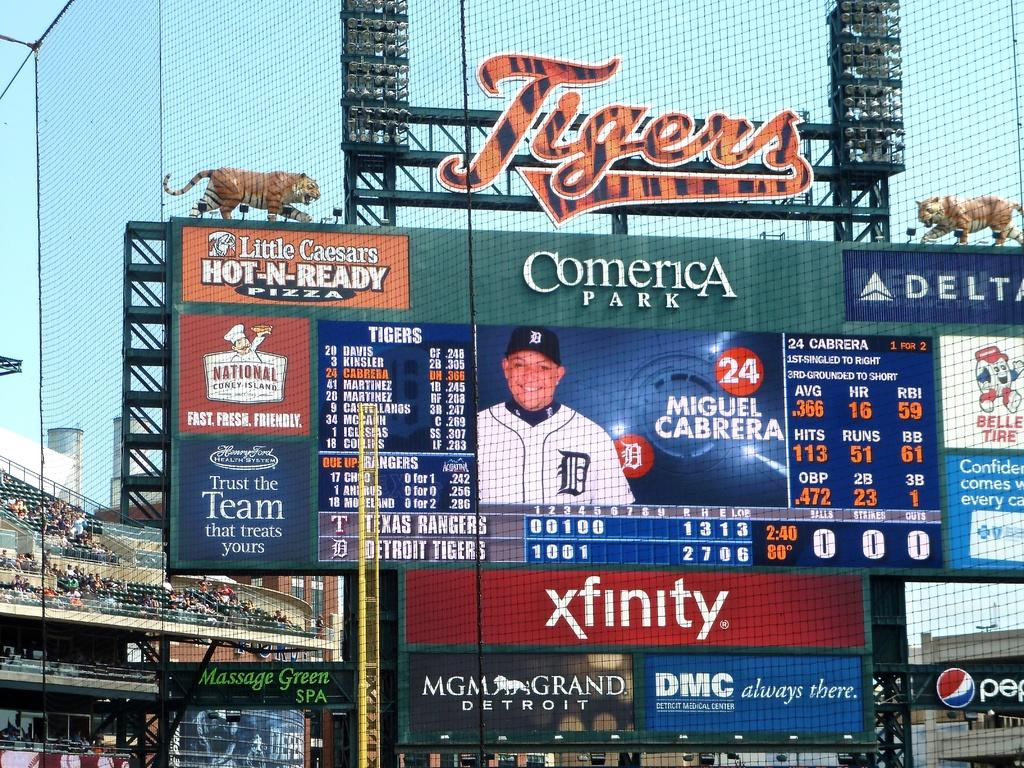<image>
Give a short and clear explanation of the subsequent image. The very busy scoreboard area of the Tigers babseball park is covered with advertising featuring Xfinity, Little Caesers, Delta and many, many more. 